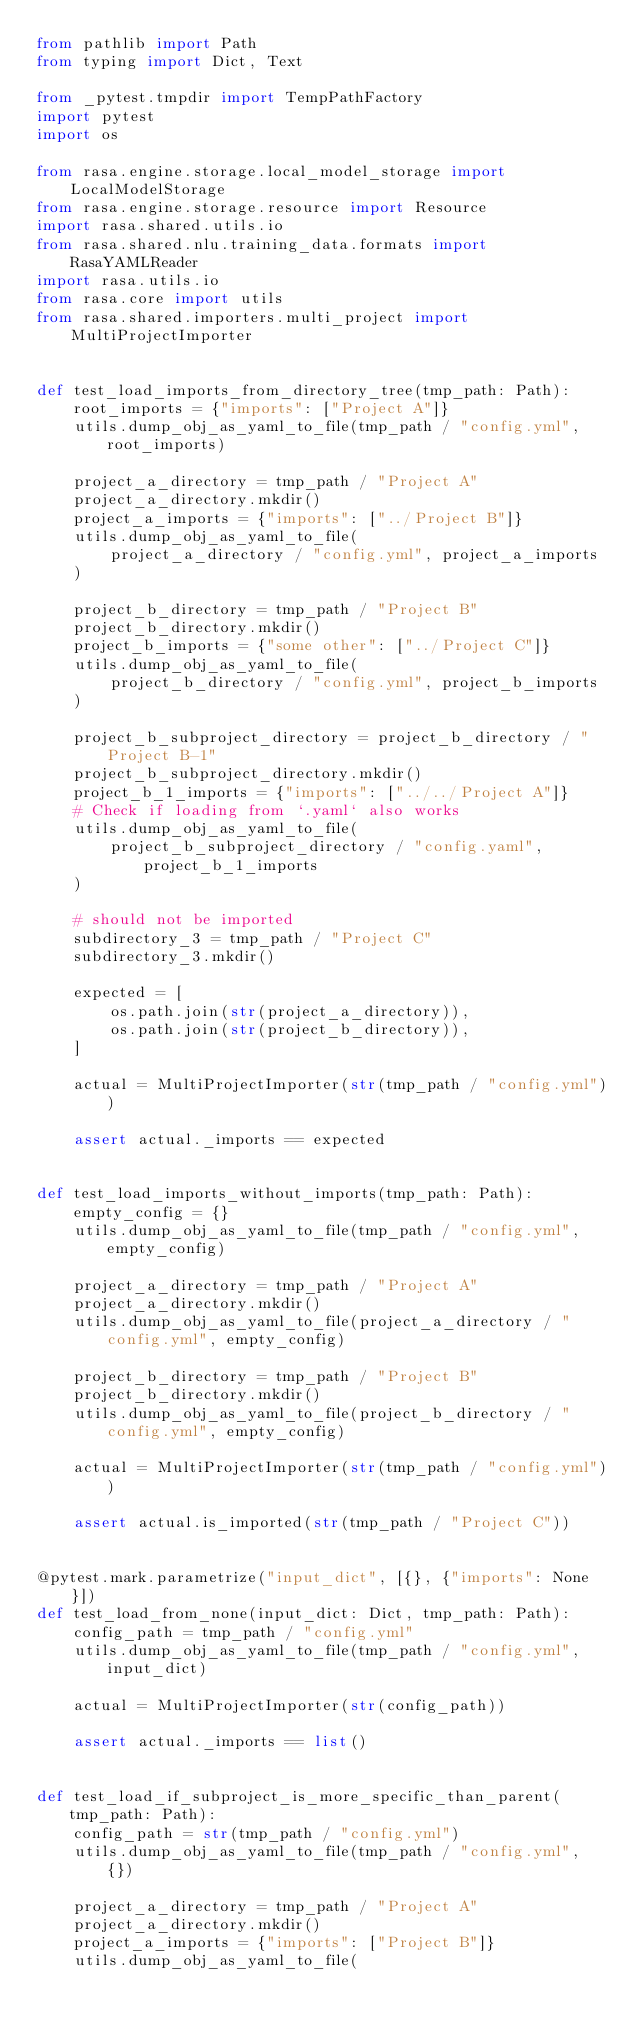Convert code to text. <code><loc_0><loc_0><loc_500><loc_500><_Python_>from pathlib import Path
from typing import Dict, Text

from _pytest.tmpdir import TempPathFactory
import pytest
import os

from rasa.engine.storage.local_model_storage import LocalModelStorage
from rasa.engine.storage.resource import Resource
import rasa.shared.utils.io
from rasa.shared.nlu.training_data.formats import RasaYAMLReader
import rasa.utils.io
from rasa.core import utils
from rasa.shared.importers.multi_project import MultiProjectImporter


def test_load_imports_from_directory_tree(tmp_path: Path):
    root_imports = {"imports": ["Project A"]}
    utils.dump_obj_as_yaml_to_file(tmp_path / "config.yml", root_imports)

    project_a_directory = tmp_path / "Project A"
    project_a_directory.mkdir()
    project_a_imports = {"imports": ["../Project B"]}
    utils.dump_obj_as_yaml_to_file(
        project_a_directory / "config.yml", project_a_imports
    )

    project_b_directory = tmp_path / "Project B"
    project_b_directory.mkdir()
    project_b_imports = {"some other": ["../Project C"]}
    utils.dump_obj_as_yaml_to_file(
        project_b_directory / "config.yml", project_b_imports
    )

    project_b_subproject_directory = project_b_directory / "Project B-1"
    project_b_subproject_directory.mkdir()
    project_b_1_imports = {"imports": ["../../Project A"]}
    # Check if loading from `.yaml` also works
    utils.dump_obj_as_yaml_to_file(
        project_b_subproject_directory / "config.yaml", project_b_1_imports
    )

    # should not be imported
    subdirectory_3 = tmp_path / "Project C"
    subdirectory_3.mkdir()

    expected = [
        os.path.join(str(project_a_directory)),
        os.path.join(str(project_b_directory)),
    ]

    actual = MultiProjectImporter(str(tmp_path / "config.yml"))

    assert actual._imports == expected


def test_load_imports_without_imports(tmp_path: Path):
    empty_config = {}
    utils.dump_obj_as_yaml_to_file(tmp_path / "config.yml", empty_config)

    project_a_directory = tmp_path / "Project A"
    project_a_directory.mkdir()
    utils.dump_obj_as_yaml_to_file(project_a_directory / "config.yml", empty_config)

    project_b_directory = tmp_path / "Project B"
    project_b_directory.mkdir()
    utils.dump_obj_as_yaml_to_file(project_b_directory / "config.yml", empty_config)

    actual = MultiProjectImporter(str(tmp_path / "config.yml"))

    assert actual.is_imported(str(tmp_path / "Project C"))


@pytest.mark.parametrize("input_dict", [{}, {"imports": None}])
def test_load_from_none(input_dict: Dict, tmp_path: Path):
    config_path = tmp_path / "config.yml"
    utils.dump_obj_as_yaml_to_file(tmp_path / "config.yml", input_dict)

    actual = MultiProjectImporter(str(config_path))

    assert actual._imports == list()


def test_load_if_subproject_is_more_specific_than_parent(tmp_path: Path):
    config_path = str(tmp_path / "config.yml")
    utils.dump_obj_as_yaml_to_file(tmp_path / "config.yml", {})

    project_a_directory = tmp_path / "Project A"
    project_a_directory.mkdir()
    project_a_imports = {"imports": ["Project B"]}
    utils.dump_obj_as_yaml_to_file(</code> 